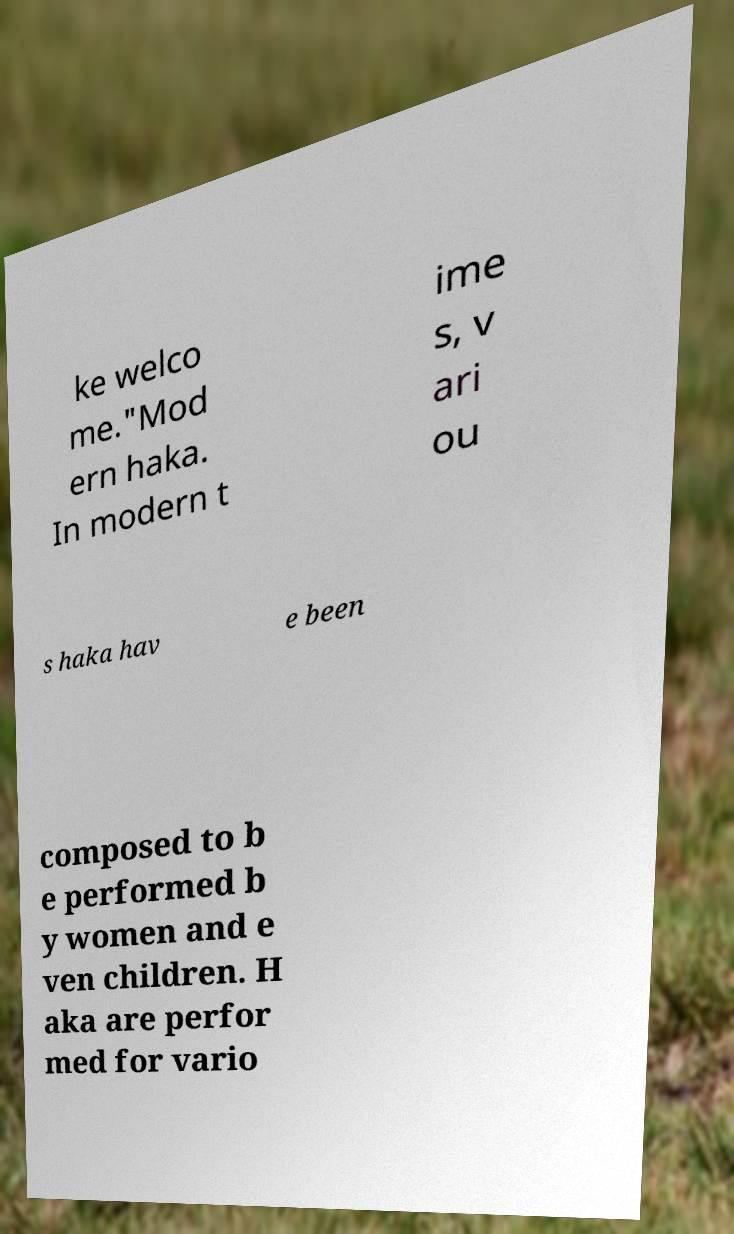What messages or text are displayed in this image? I need them in a readable, typed format. ke welco me."Mod ern haka. In modern t ime s, v ari ou s haka hav e been composed to b e performed b y women and e ven children. H aka are perfor med for vario 